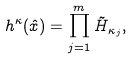Convert formula to latex. <formula><loc_0><loc_0><loc_500><loc_500>h ^ { \kappa } ( \hat { x } ) = \prod _ { j = 1 } ^ { m } \tilde { H } _ { \kappa _ { j } } ,</formula> 